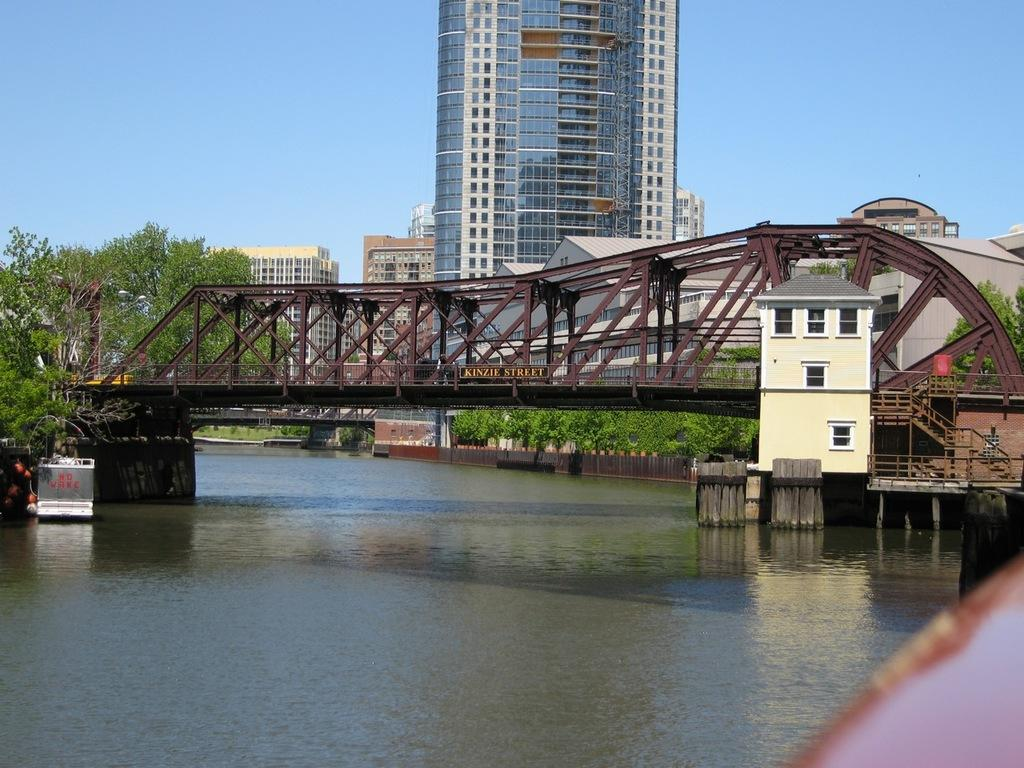What structure can be seen in the image? There is a bridge in the image. What is the bridge positioned over? The bridge is over water. What else can be seen in the image besides the bridge? There are buildings, trees, and steps in the image. What is visible in the background of the image? The sky is visible in the background of the image. What type of dolls can be seen playing with sticks in the image? There are no dolls or sticks present in the image. 